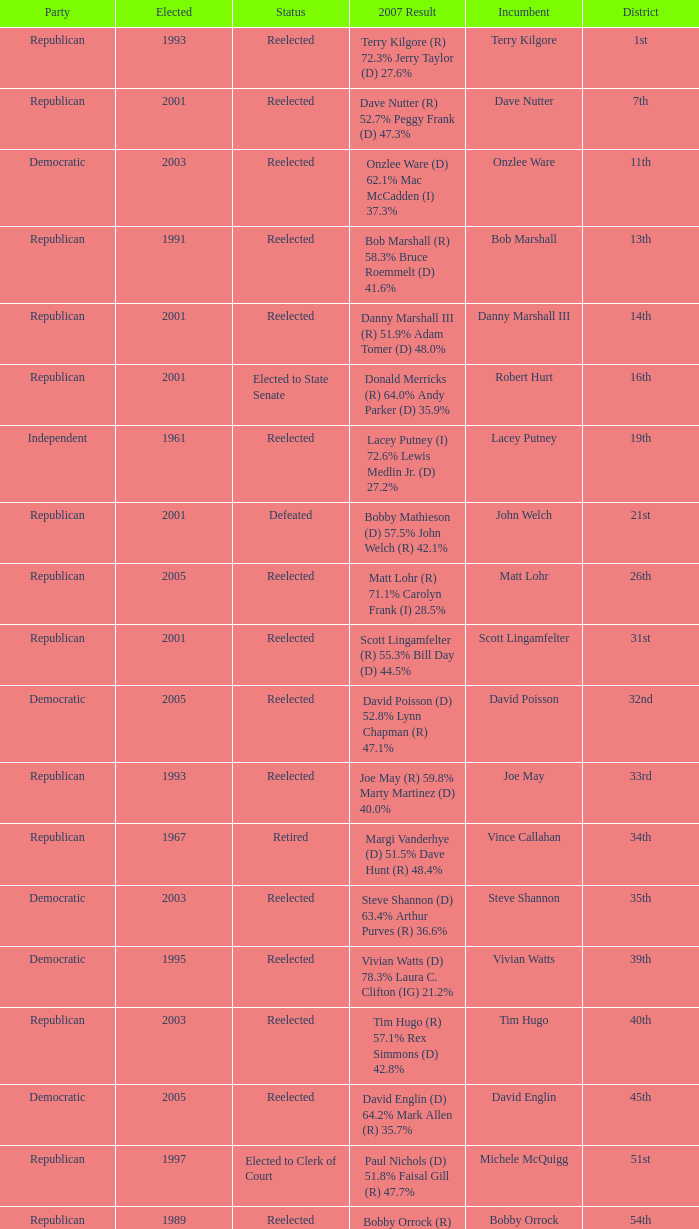What was the last year someone was elected to the 14th district? 2001.0. 